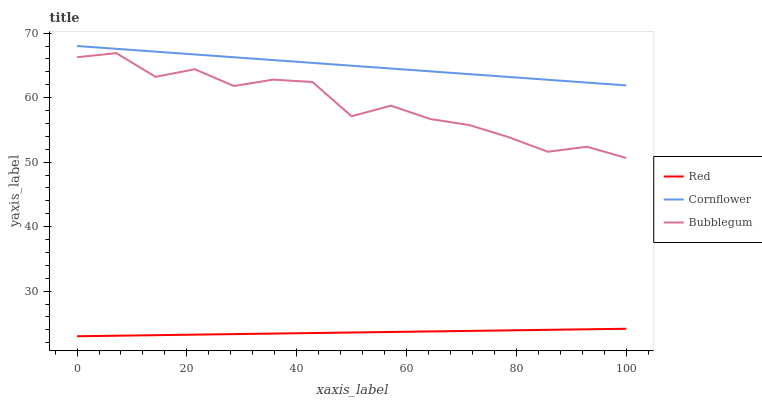Does Bubblegum have the minimum area under the curve?
Answer yes or no. No. Does Bubblegum have the maximum area under the curve?
Answer yes or no. No. Is Bubblegum the smoothest?
Answer yes or no. No. Is Red the roughest?
Answer yes or no. No. Does Bubblegum have the lowest value?
Answer yes or no. No. Does Bubblegum have the highest value?
Answer yes or no. No. Is Bubblegum less than Cornflower?
Answer yes or no. Yes. Is Cornflower greater than Red?
Answer yes or no. Yes. Does Bubblegum intersect Cornflower?
Answer yes or no. No. 